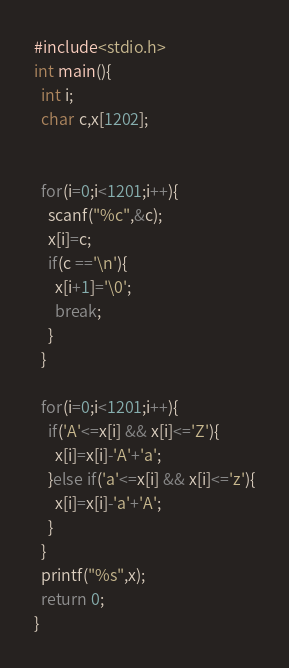<code> <loc_0><loc_0><loc_500><loc_500><_C_>#include<stdio.h>
int main(){
  int i;
  char c,x[1202];


  for(i=0;i<1201;i++){
    scanf("%c",&c);
    x[i]=c;
    if(c =='\n'){
      x[i+1]='\0';
      break;
    }
  }

  for(i=0;i<1201;i++){
    if('A'<=x[i] && x[i]<='Z'){
      x[i]=x[i]-'A'+'a';
    }else if('a'<=x[i] && x[i]<='z'){
      x[i]=x[i]-'a'+'A';
    }
  }
  printf("%s",x);
  return 0;
}</code> 